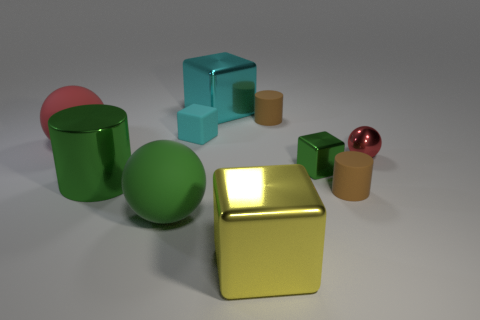Subtract all green blocks. How many blocks are left? 3 Subtract all small green blocks. How many blocks are left? 3 Subtract all balls. How many objects are left? 7 Add 6 large cylinders. How many large cylinders are left? 7 Add 10 small gray things. How many small gray things exist? 10 Subtract 1 green cylinders. How many objects are left? 9 Subtract all small metal objects. Subtract all big cyan shiny things. How many objects are left? 7 